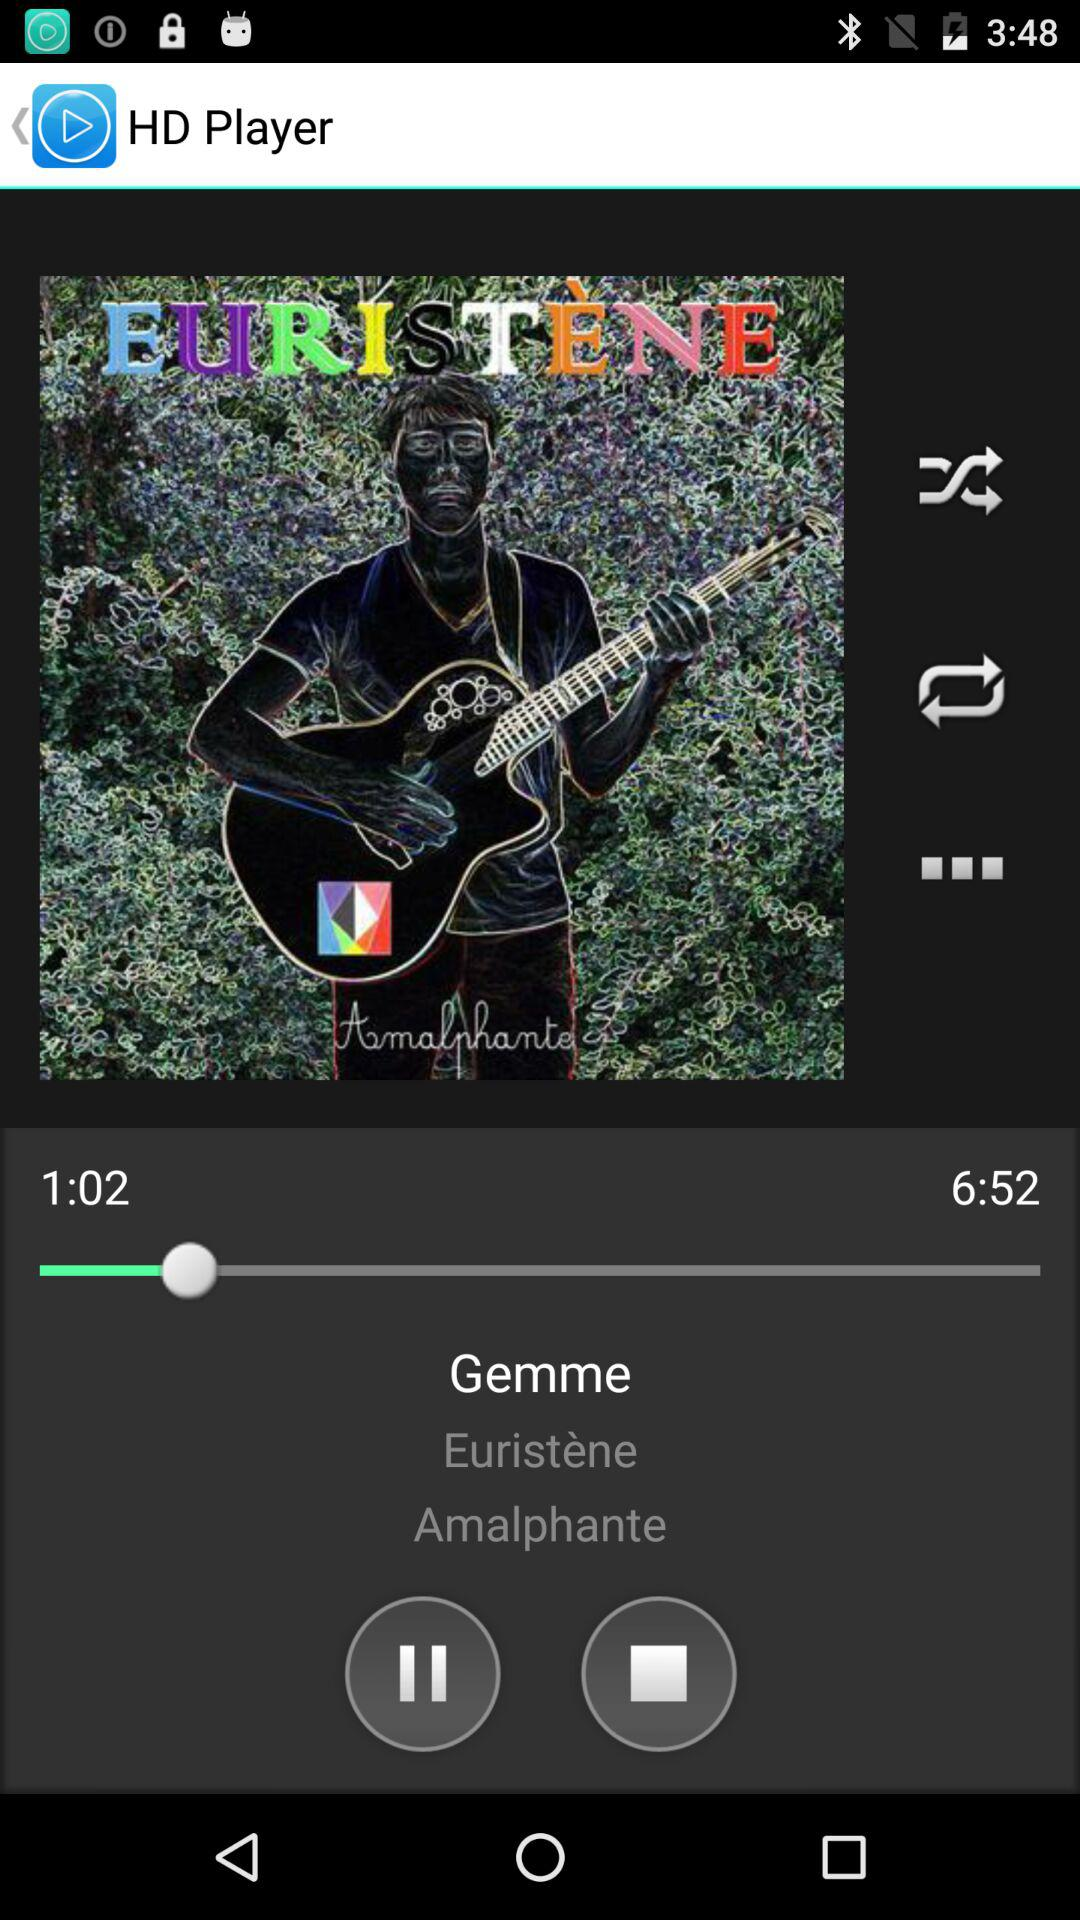Who is the artist of the song? The artist is Gemme. 